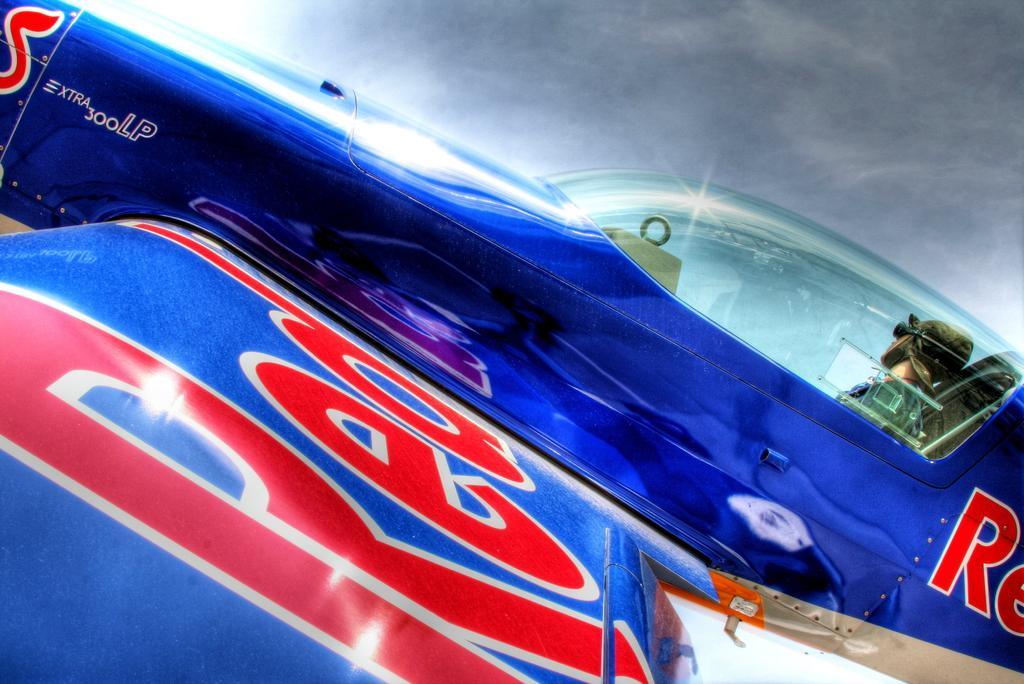<image>
Summarize the visual content of the image. A pilot is in the cockpit of a blue plane that has the word "red" on the wing. 